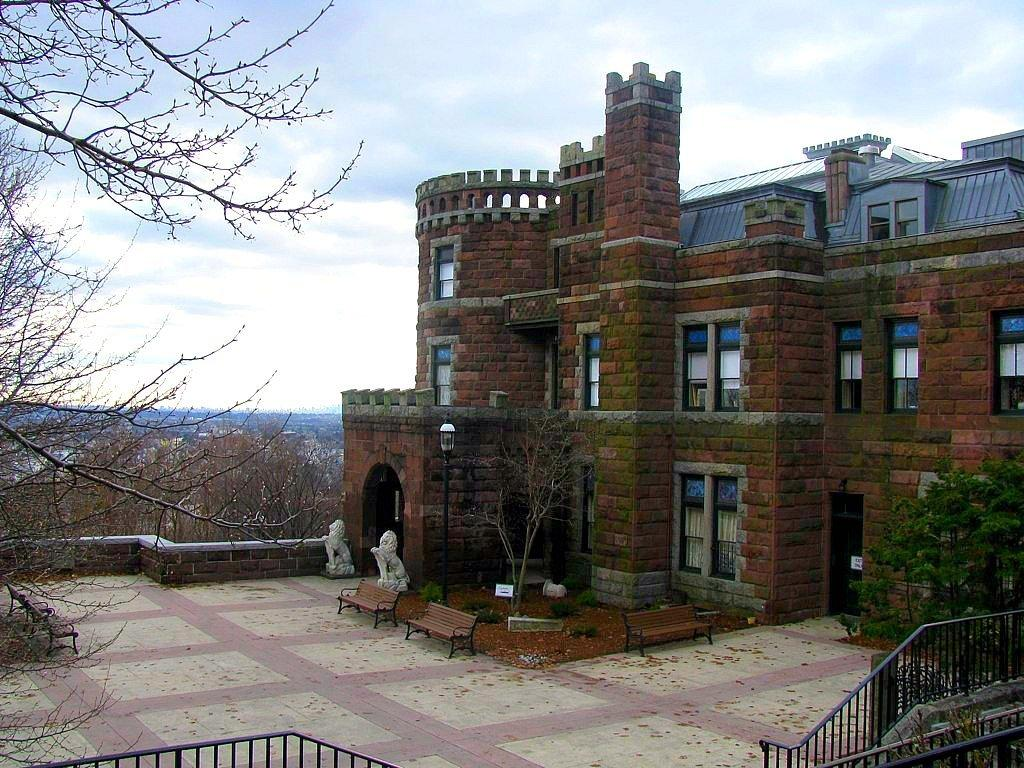What type of structure is visible in the image? There is a building in the image. What other natural elements can be seen in the image? There are trees in the image. How would you describe the sky in the image? The sky is blue and cloudy in the image. Are there any seating areas visible in the image? Yes, there are benches in the image. What type of stove is being used in the prison during the afternoon in the image? There is no stove, prison, or reference to an afternoon in the image. 